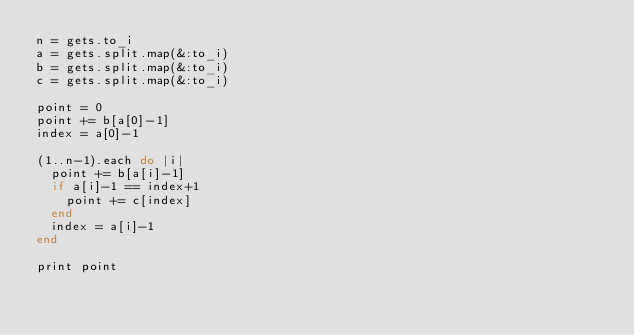<code> <loc_0><loc_0><loc_500><loc_500><_Ruby_>n = gets.to_i
a = gets.split.map(&:to_i)
b = gets.split.map(&:to_i)
c = gets.split.map(&:to_i)

point = 0
point += b[a[0]-1]
index = a[0]-1

(1..n-1).each do |i|
  point += b[a[i]-1]
  if a[i]-1 == index+1
    point += c[index]
  end
  index = a[i]-1
end

print point</code> 